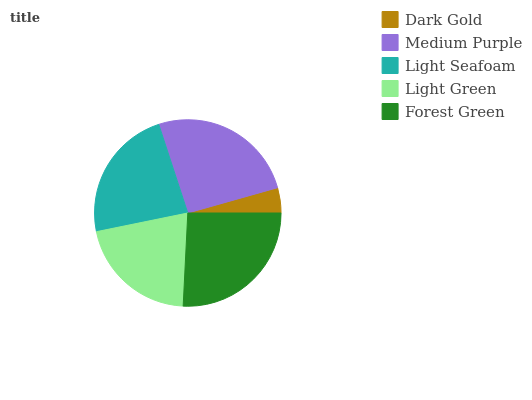Is Dark Gold the minimum?
Answer yes or no. Yes. Is Forest Green the maximum?
Answer yes or no. Yes. Is Medium Purple the minimum?
Answer yes or no. No. Is Medium Purple the maximum?
Answer yes or no. No. Is Medium Purple greater than Dark Gold?
Answer yes or no. Yes. Is Dark Gold less than Medium Purple?
Answer yes or no. Yes. Is Dark Gold greater than Medium Purple?
Answer yes or no. No. Is Medium Purple less than Dark Gold?
Answer yes or no. No. Is Light Seafoam the high median?
Answer yes or no. Yes. Is Light Seafoam the low median?
Answer yes or no. Yes. Is Medium Purple the high median?
Answer yes or no. No. Is Dark Gold the low median?
Answer yes or no. No. 